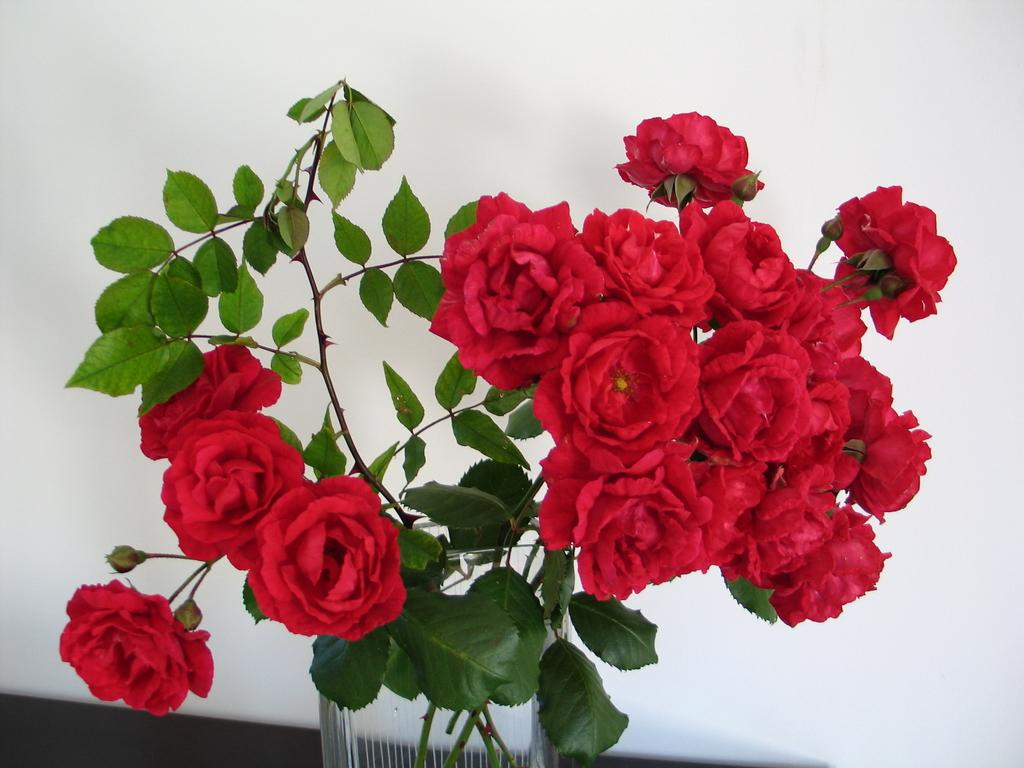What type of plant is in the image? There is a rose plant in the image. How is the rose plant contained or displayed? The rose plant is in a glass pot. What can be seen behind the plant in the image? There is a white color wall behind the plant. How many sheep are visible in the image? There are no sheep present in the image. What type of muscle is being exercised by the plant in the image? Plants do not have muscles, so this question is not applicable to the image. 